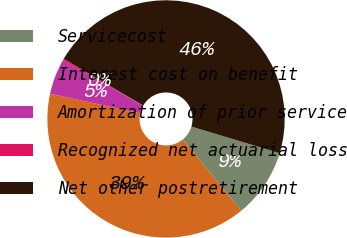<chart> <loc_0><loc_0><loc_500><loc_500><pie_chart><fcel>Servicecost<fcel>Interest cost on benefit<fcel>Amortization of prior service<fcel>Recognized net actuarial loss<fcel>Net other postretirement<nl><fcel>9.42%<fcel>39.33%<fcel>4.82%<fcel>0.23%<fcel>46.2%<nl></chart> 